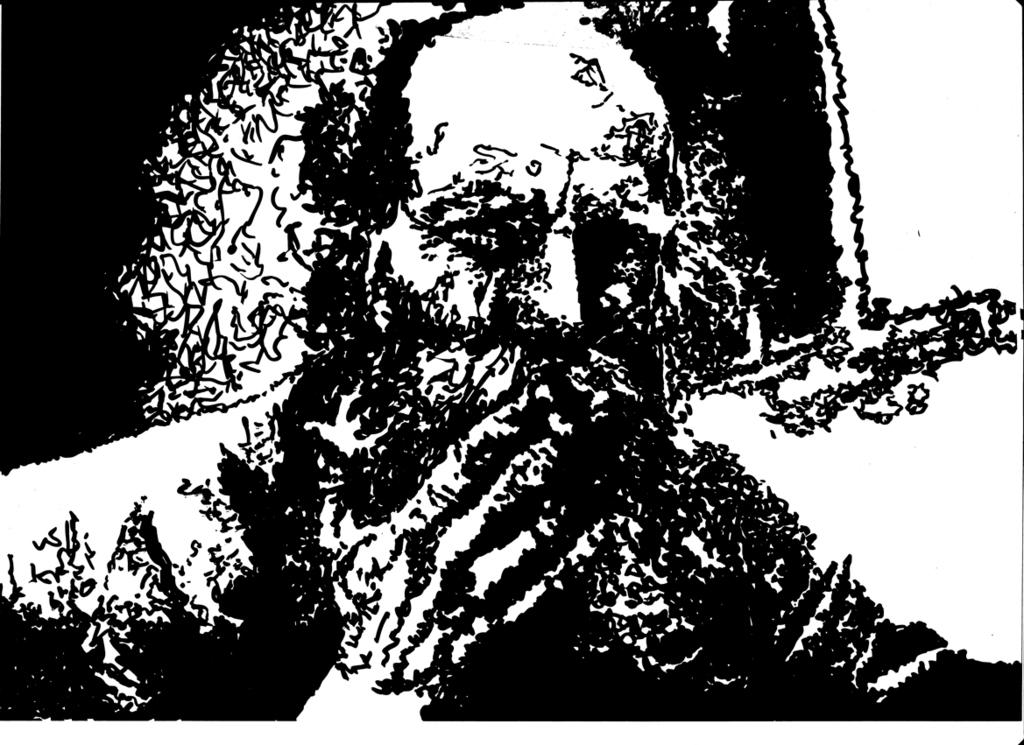What type of image is being described? The image is an edited picture. Can you describe the content of the image? There is a person in the image. How many girls can be seen dancing in the rain under the moon in the image? There is no mention of girls, rain, or the moon in the image. The image only contains an edited picture with a person present. 